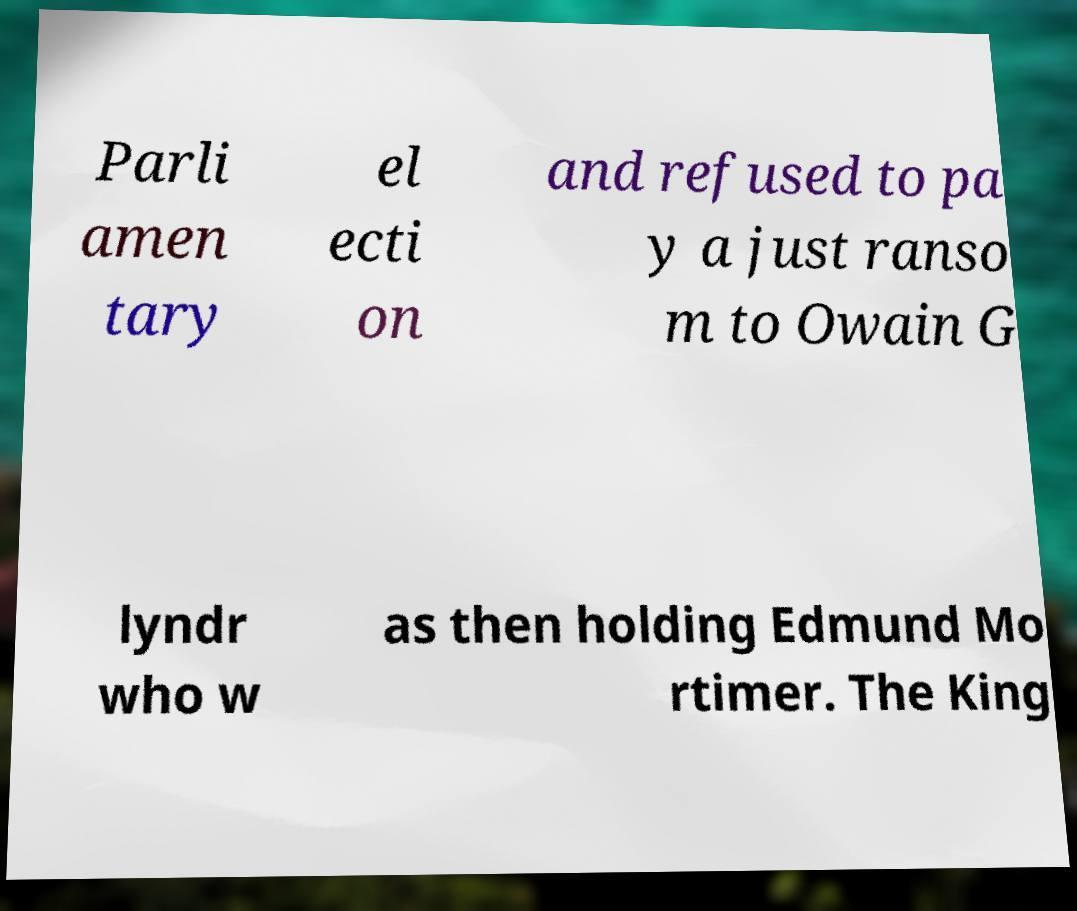For documentation purposes, I need the text within this image transcribed. Could you provide that? Parli amen tary el ecti on and refused to pa y a just ranso m to Owain G lyndr who w as then holding Edmund Mo rtimer. The King 